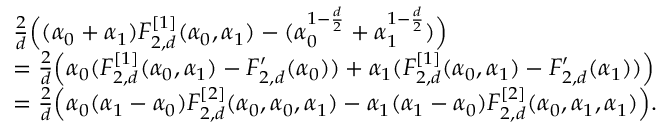Convert formula to latex. <formula><loc_0><loc_0><loc_500><loc_500>\begin{array} { r l } & { \frac { 2 } { d } \left ( ( \alpha _ { 0 } + \alpha _ { 1 } ) F _ { 2 , d } ^ { [ 1 ] } ( \alpha _ { 0 } , \alpha _ { 1 } ) - ( \alpha _ { 0 } ^ { 1 - \frac { d } { 2 } } + \alpha _ { 1 } ^ { 1 - \frac { d } { 2 } } ) \right ) } \\ & { = \frac { 2 } { d } \left ( \alpha _ { 0 } ( F _ { 2 , d } ^ { [ 1 ] } ( \alpha _ { 0 } , \alpha _ { 1 } ) - F _ { 2 , d } ^ { \prime } ( \alpha _ { 0 } ) ) + \alpha _ { 1 } ( F _ { 2 , d } ^ { [ 1 ] } ( \alpha _ { 0 } , \alpha _ { 1 } ) - F _ { 2 , d } ^ { \prime } ( \alpha _ { 1 } ) ) \right ) } \\ & { = \frac { 2 } { d } \left ( \alpha _ { 0 } ( \alpha _ { 1 } - \alpha _ { 0 } ) F _ { 2 , d } ^ { [ 2 ] } ( \alpha _ { 0 } , \alpha _ { 0 } , \alpha _ { 1 } ) - \alpha _ { 1 } ( \alpha _ { 1 } - \alpha _ { 0 } ) F _ { 2 , d } ^ { [ 2 ] } ( \alpha _ { 0 } , \alpha _ { 1 } , \alpha _ { 1 } ) \right ) . } \end{array}</formula> 